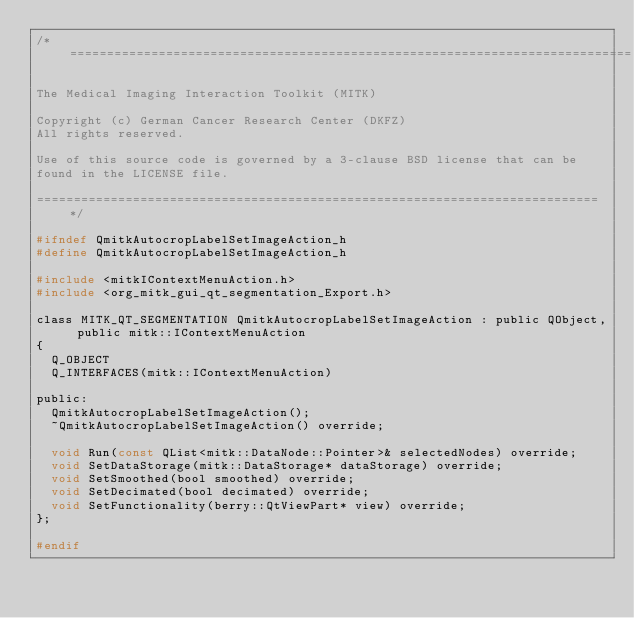<code> <loc_0><loc_0><loc_500><loc_500><_C_>/*============================================================================

The Medical Imaging Interaction Toolkit (MITK)

Copyright (c) German Cancer Research Center (DKFZ)
All rights reserved.

Use of this source code is governed by a 3-clause BSD license that can be
found in the LICENSE file.

============================================================================*/

#ifndef QmitkAutocropLabelSetImageAction_h
#define QmitkAutocropLabelSetImageAction_h

#include <mitkIContextMenuAction.h>
#include <org_mitk_gui_qt_segmentation_Export.h>

class MITK_QT_SEGMENTATION QmitkAutocropLabelSetImageAction : public QObject, public mitk::IContextMenuAction
{
  Q_OBJECT
  Q_INTERFACES(mitk::IContextMenuAction)

public:
  QmitkAutocropLabelSetImageAction();
  ~QmitkAutocropLabelSetImageAction() override;

  void Run(const QList<mitk::DataNode::Pointer>& selectedNodes) override;
  void SetDataStorage(mitk::DataStorage* dataStorage) override;
  void SetSmoothed(bool smoothed) override;
  void SetDecimated(bool decimated) override;
  void SetFunctionality(berry::QtViewPart* view) override;
};

#endif
</code> 